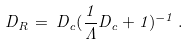<formula> <loc_0><loc_0><loc_500><loc_500>D _ { R } \, = \, D _ { c } ( \frac { 1 } { \Lambda } D _ { c } + 1 ) ^ { - 1 } \, .</formula> 